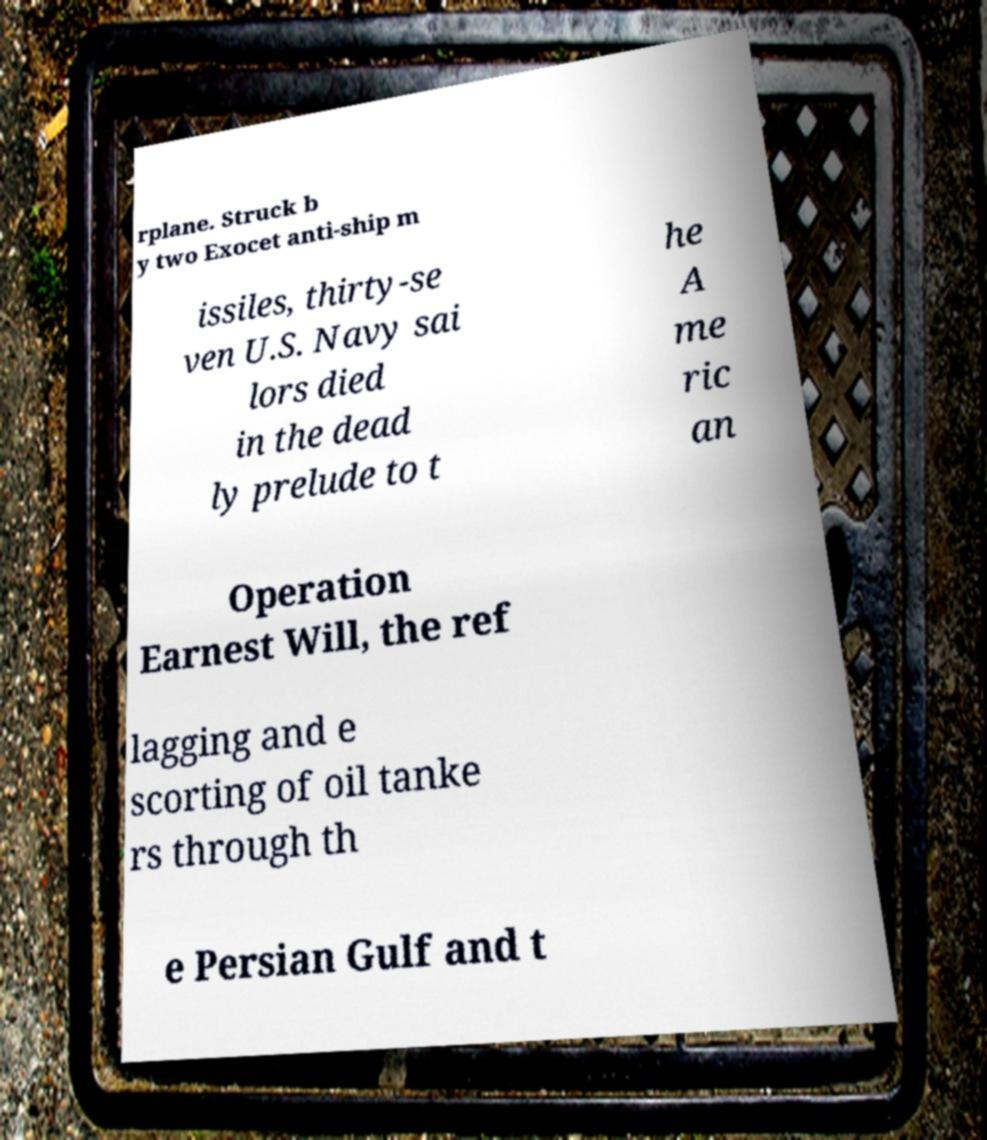Please read and relay the text visible in this image. What does it say? rplane. Struck b y two Exocet anti-ship m issiles, thirty-se ven U.S. Navy sai lors died in the dead ly prelude to t he A me ric an Operation Earnest Will, the ref lagging and e scorting of oil tanke rs through th e Persian Gulf and t 